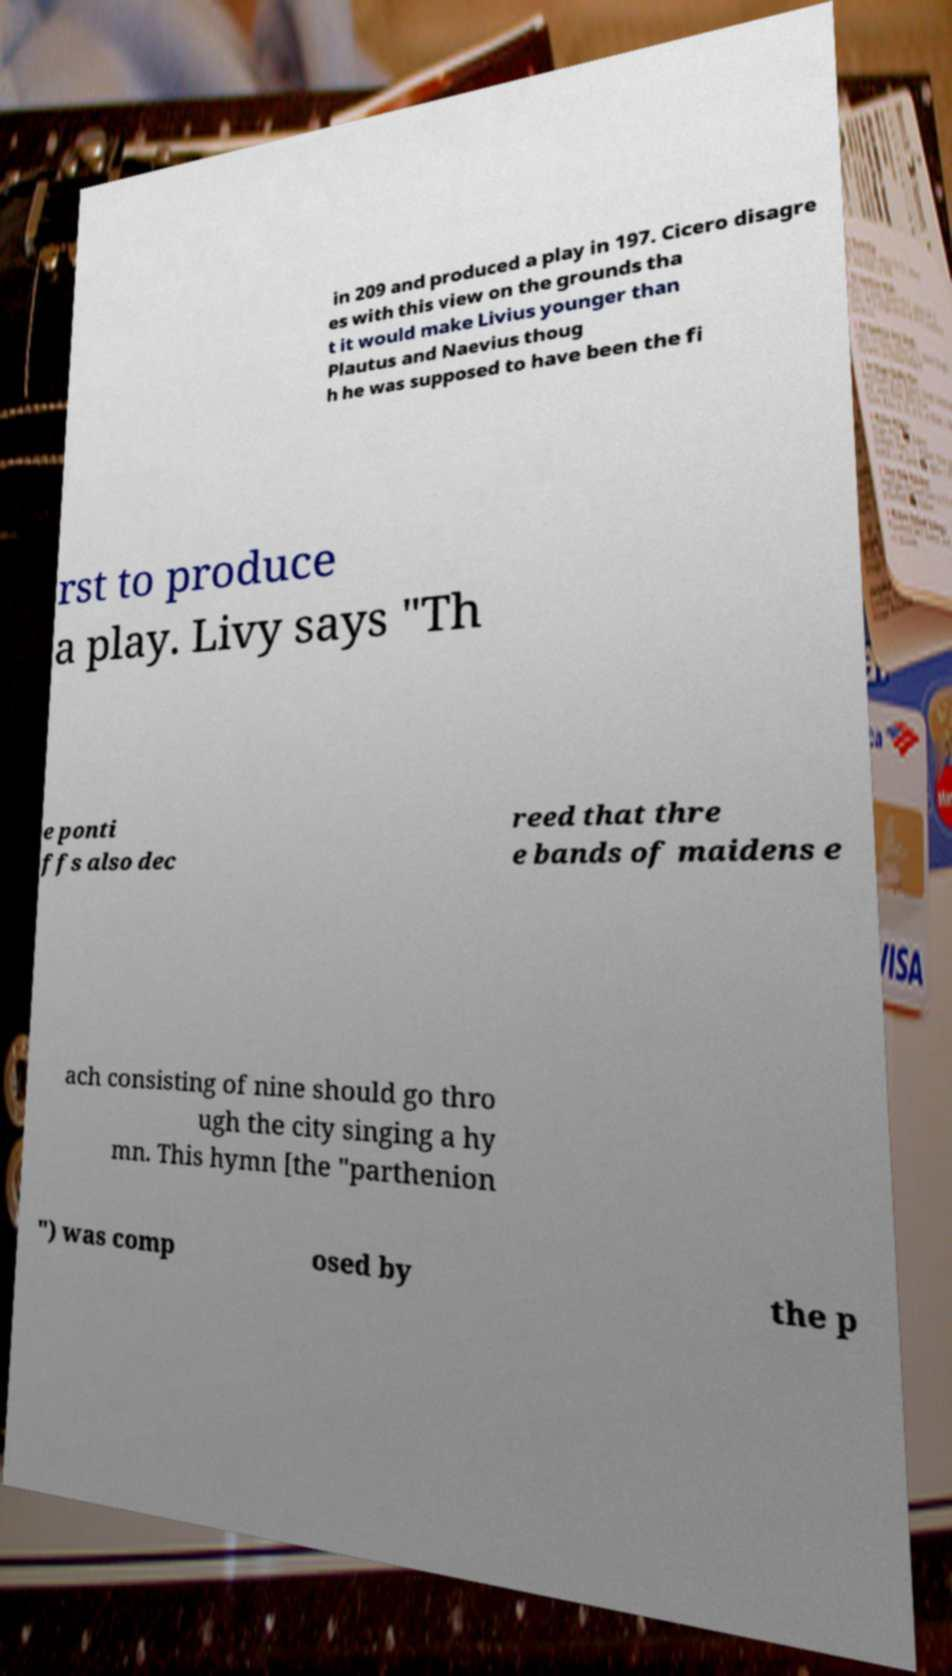What messages or text are displayed in this image? I need them in a readable, typed format. in 209 and produced a play in 197. Cicero disagre es with this view on the grounds tha t it would make Livius younger than Plautus and Naevius thoug h he was supposed to have been the fi rst to produce a play. Livy says "Th e ponti ffs also dec reed that thre e bands of maidens e ach consisting of nine should go thro ugh the city singing a hy mn. This hymn [the "parthenion ") was comp osed by the p 